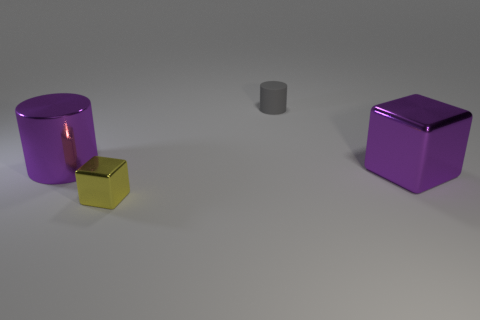Is the material of the large purple object that is left of the small cylinder the same as the small object that is behind the small metal block?
Make the answer very short. No. Are there fewer objects that are in front of the tiny gray matte object than things?
Give a very brief answer. Yes. There is another thing that is the same shape as the rubber thing; what is its color?
Make the answer very short. Purple. There is a yellow shiny cube that is left of the gray cylinder; does it have the same size as the purple metal cube?
Make the answer very short. No. There is a metal thing that is in front of the metallic cube on the right side of the gray cylinder; what is its size?
Offer a terse response. Small. Are the small yellow cube and the cylinder in front of the gray matte object made of the same material?
Provide a succinct answer. Yes. Are there fewer cylinders that are to the right of the tiny gray rubber cylinder than things that are to the left of the large purple metallic block?
Ensure brevity in your answer.  Yes. What color is the small block that is the same material as the big purple cylinder?
Offer a very short reply. Yellow. Is there a big purple metal object that is in front of the cylinder in front of the small gray cylinder?
Keep it short and to the point. Yes. There is a object that is the same size as the purple block; what is its color?
Give a very brief answer. Purple. 